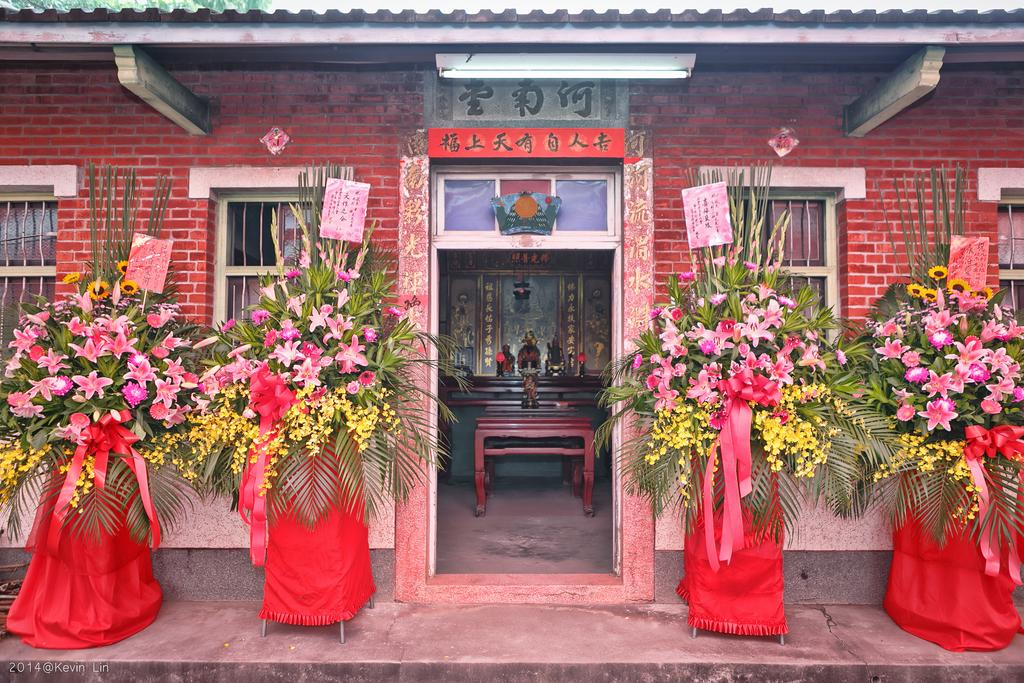What is located beside the door in the image? There are four plants beside the door in the image. What can be seen on the door itself? There are flowers on the door in the image. What type of cable is connected to the plants beside the door? There is no cable connected to the plants beside the door in the image. How does the belief system of the person who placed the flowers on the door influence their choice of flowers? The provided facts do not mention any belief system or person responsible for placing the flowers on the door, so we cannot determine how their belief system might influence their choice of flowers. 